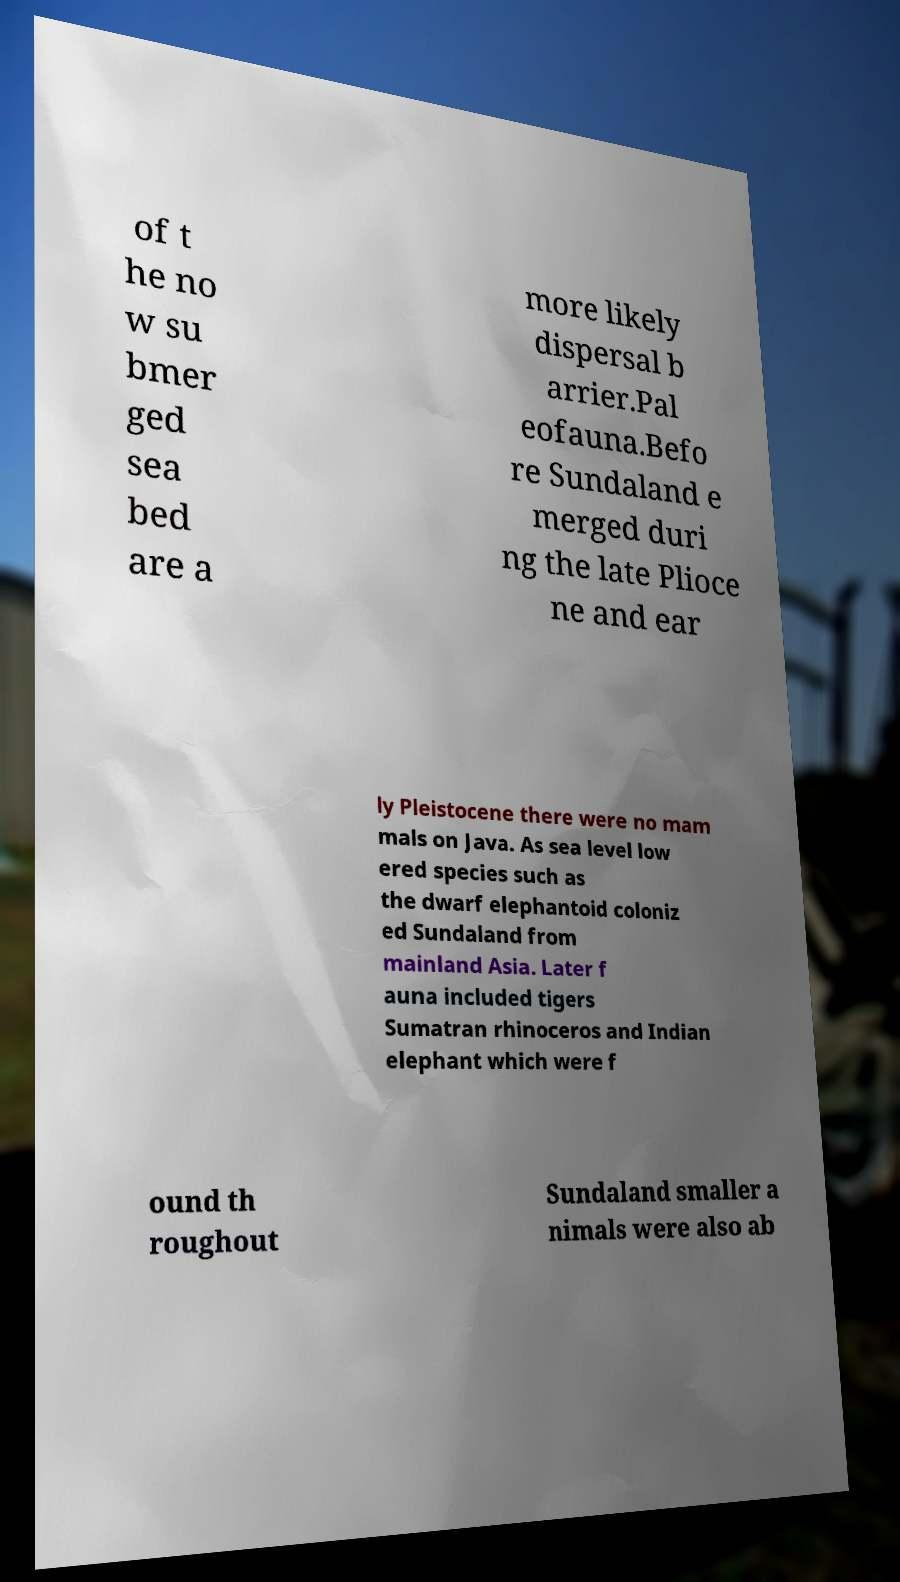There's text embedded in this image that I need extracted. Can you transcribe it verbatim? of t he no w su bmer ged sea bed are a more likely dispersal b arrier.Pal eofauna.Befo re Sundaland e merged duri ng the late Plioce ne and ear ly Pleistocene there were no mam mals on Java. As sea level low ered species such as the dwarf elephantoid coloniz ed Sundaland from mainland Asia. Later f auna included tigers Sumatran rhinoceros and Indian elephant which were f ound th roughout Sundaland smaller a nimals were also ab 